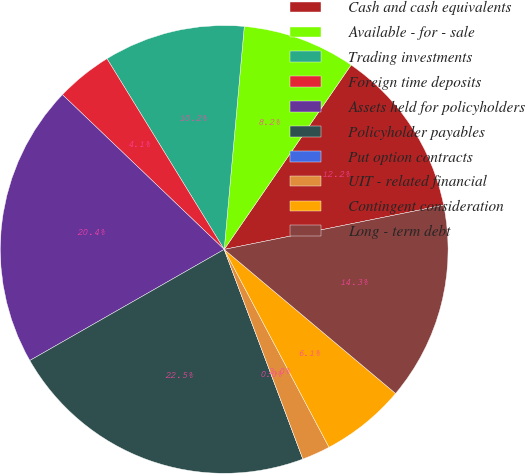Convert chart. <chart><loc_0><loc_0><loc_500><loc_500><pie_chart><fcel>Cash and cash equivalents<fcel>Available - for - sale<fcel>Trading investments<fcel>Foreign time deposits<fcel>Assets held for policyholders<fcel>Policyholder payables<fcel>Put option contracts<fcel>UIT - related financial<fcel>Contingent consideration<fcel>Long - term debt<nl><fcel>12.24%<fcel>8.16%<fcel>10.2%<fcel>4.08%<fcel>20.41%<fcel>22.45%<fcel>0.0%<fcel>2.04%<fcel>6.12%<fcel>14.29%<nl></chart> 